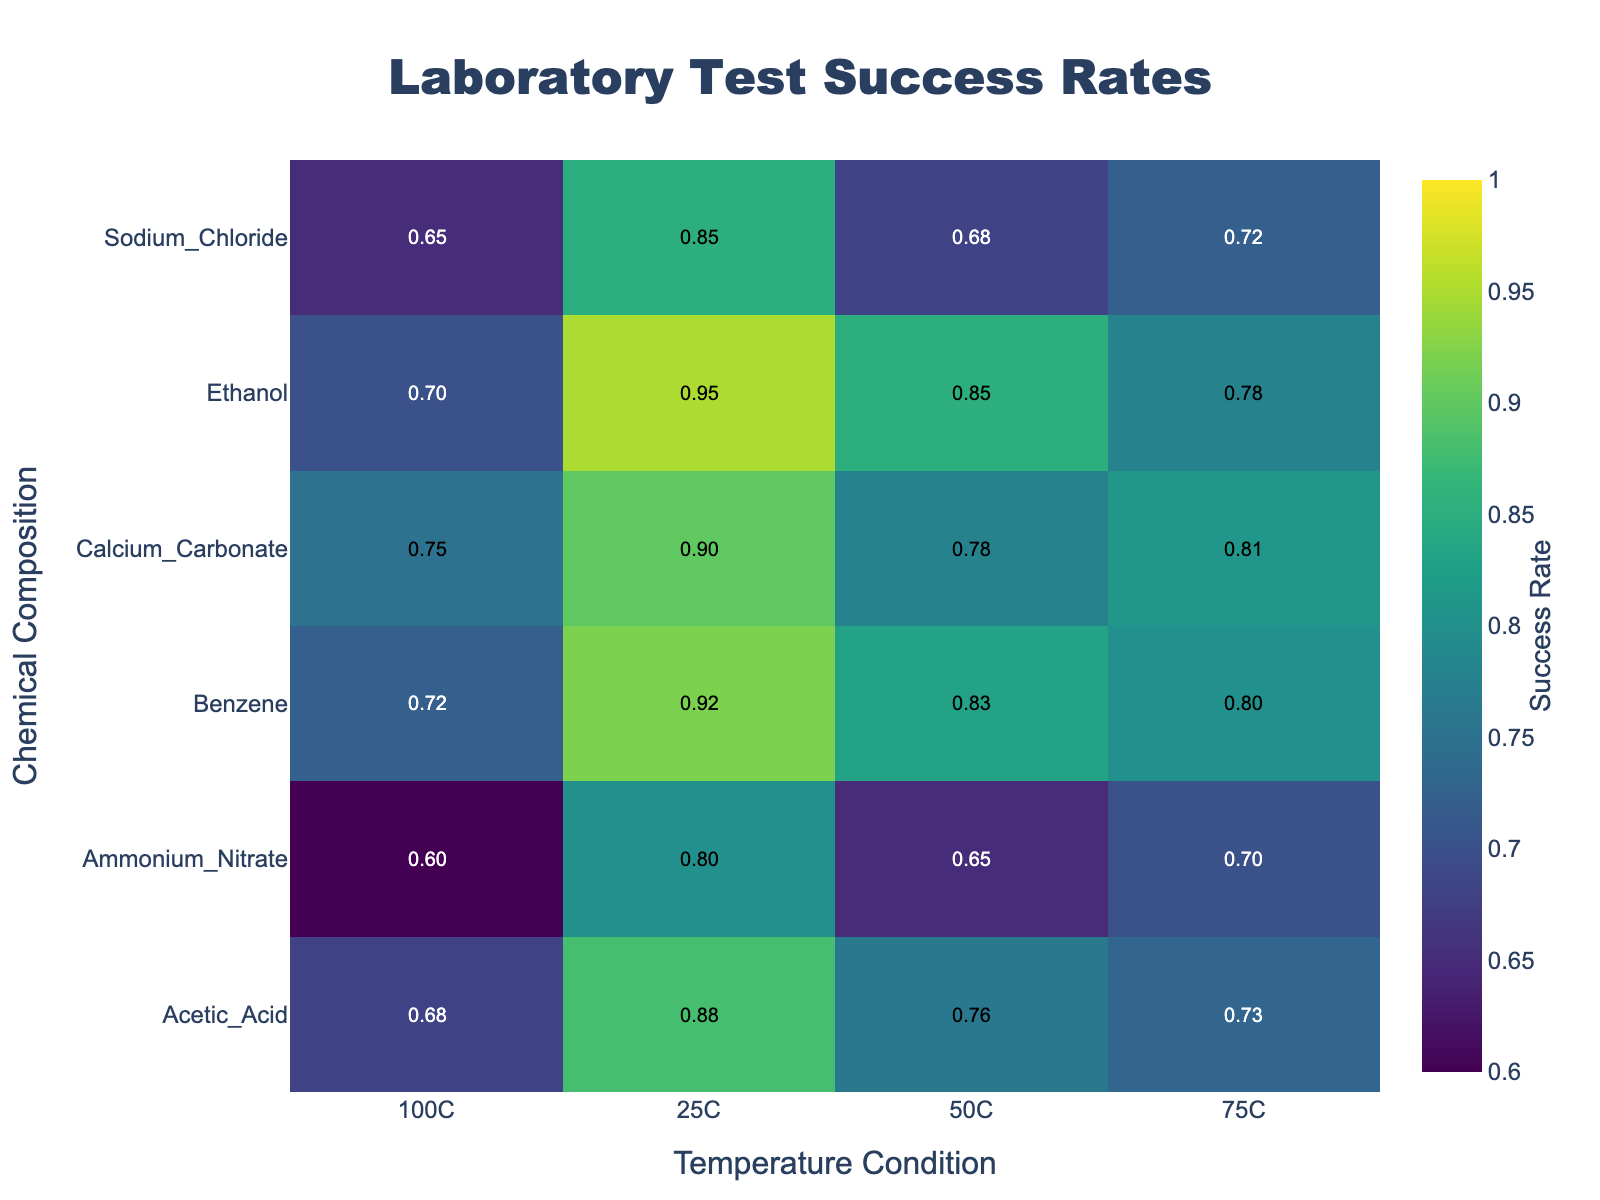What is the temperature condition with the highest success rate for Benzene? Look at the row corresponding to Benzene and identify the highest value in that row. The maximum value is 0.92, which is associated with the temperature condition 25C.
Answer: 25C Which chemical composition has the highest success rate at 100C? Look at the column corresponding to 100C and find the highest value within that column. The highest value is 0.75 and it corresponds to Calcium Carbonate.
Answer: Calcium Carbonate What's the average success rate for Sodium Chloride across all temperatures? Sum the success rates for Sodium Chloride at all temperatures and divide by the number of temperature conditions (4). The success rates are 0.85, 0.68, 0.72, and 0.65. Adding them gives 2.90; dividing by 4 gives an average of 0.725.
Answer: 0.725 How does the success rate of Ammonium Nitrate at 50C compare to its rate at 75C? Look at the values for Ammonium Nitrate in the 50C and 75C columns. The success rate at 50C is 0.65 and at 75C it is 0.70. Compare these two values; 0.65 is less than 0.70.
Answer: 0.65 is less than 0.70 What is the range of success rates for Ethanol across all temperature conditions? Find the minimum and maximum values for Ethanol across all temperatures. The success rates are 0.95, 0.85, 0.78, and 0.70. The range is the difference between the maximum and minimum values: 0.95 - 0.70 = 0.25.
Answer: 0.25 Which chemical composition has the lowest success rate regardless of temperature? Identify the lowest value across the entire heatmap. The minimum value is 0.60 which corresponds to Ammonium Nitrate at 100C.
Answer: Ammonium Nitrate At 50C, which chemical composition has a higher success rate, Calcium Carbonate or Acetic Acid? Compare the values for Calcium Carbonate and Acetic Acid in the 50C column. Calcium Carbonate has a success rate of 0.78, whereas Acetic Acid has 0.76. 0.78 is higher than 0.76.
Answer: Calcium Carbonate What is the median success rate for all chemical compositions at 75C? List the success rates for all chemicals at 75C: 0.72, 0.81, 0.70, 0.78, 0.73, 0.80. Order these values: 0.70, 0.72, 0.73, 0.78, 0.80, 0.81. The median is the average of the middle two values: (0.73 + 0.78)/2 = 0.755.
Answer: 0.755 